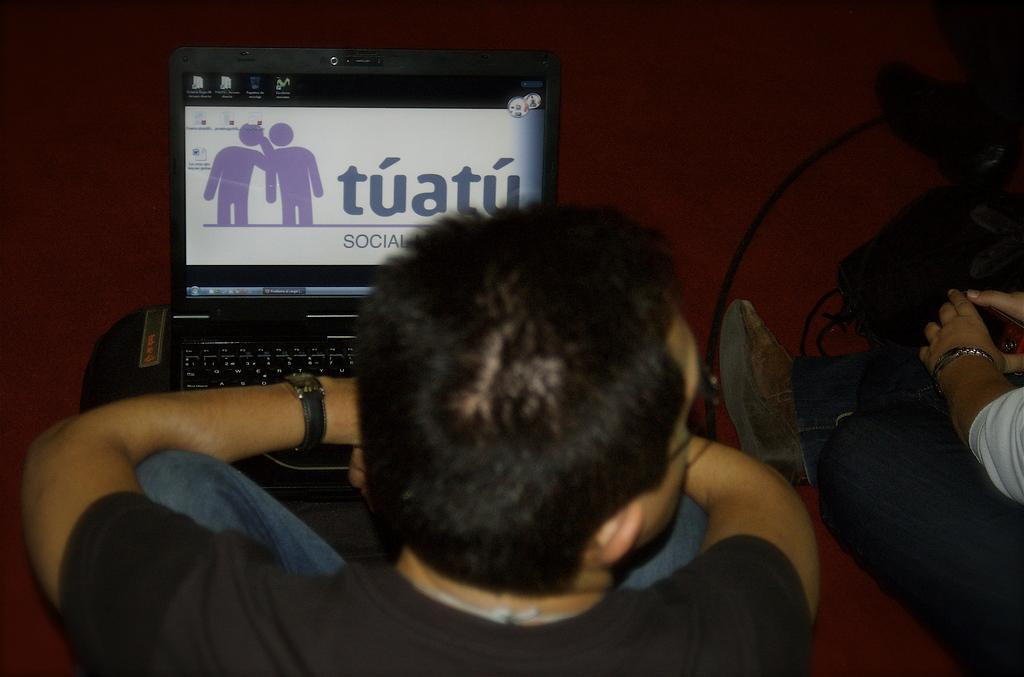<image>
Write a terse but informative summary of the picture. A computer screen with the word tuatu is in front of a man. 